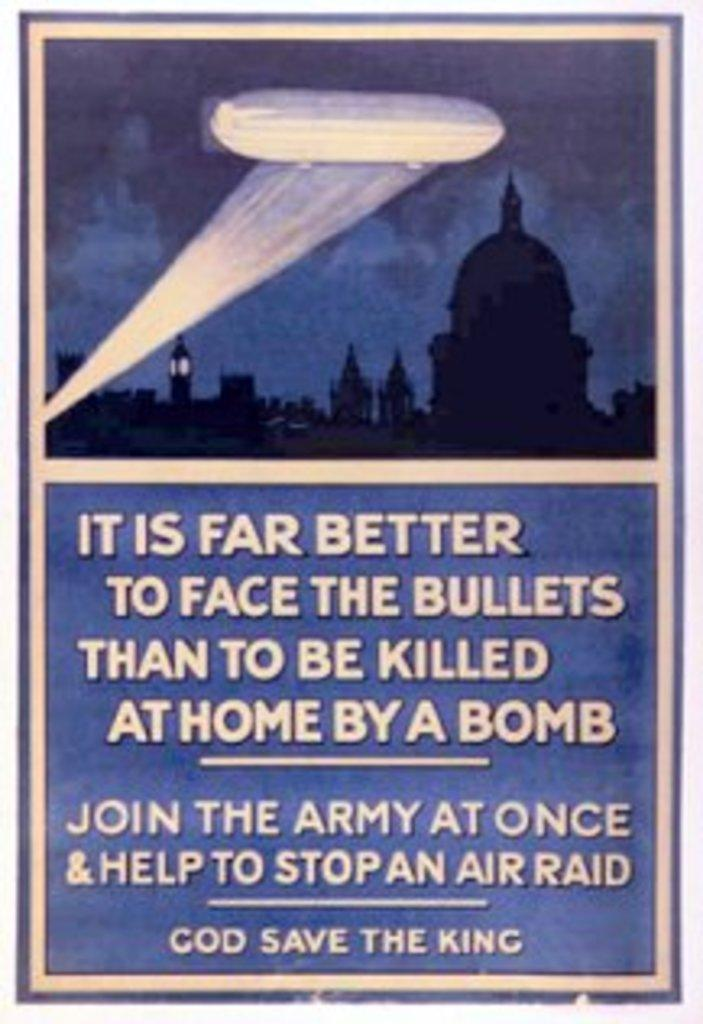What type of image is shown in the poster? The image is a poster that depicts ancient architecture. What can be found on the poster besides the image? There is text written on the poster. What type of sack is shown in the poster? There is no sack present in the poster; it depicts ancient architecture and text. What is served for breakfast in the poster? There is no reference to breakfast or any food items in the poster; it focuses on ancient architecture and text. 